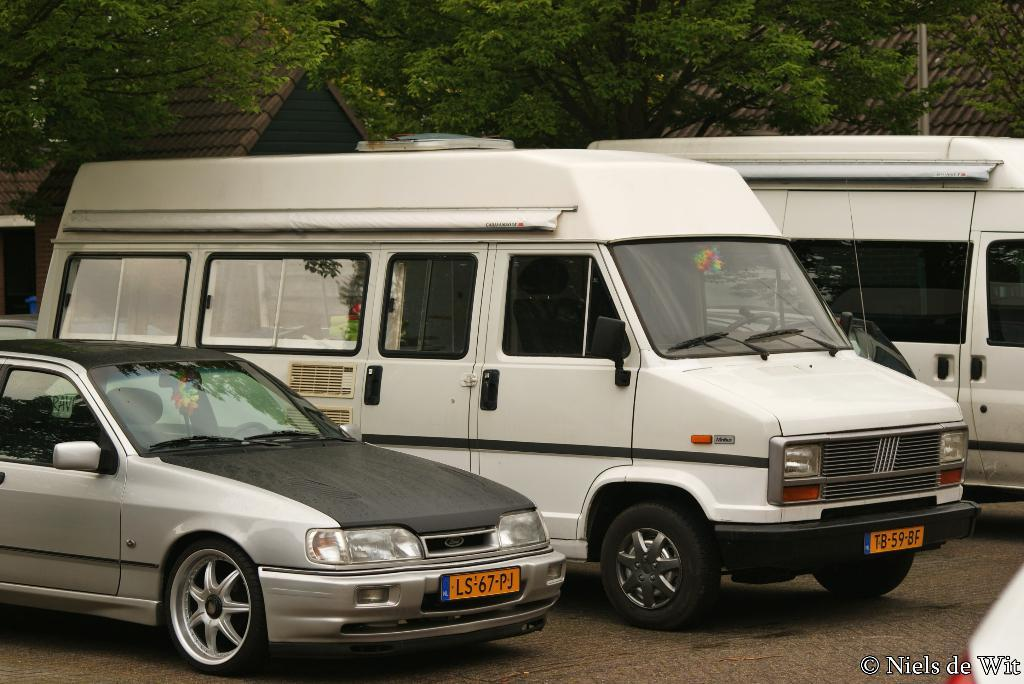<image>
Offer a succinct explanation of the picture presented. A gray Ford car is parked next to a white van. 